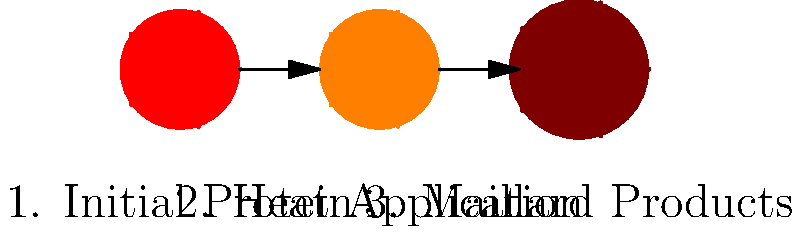As a BBQ Pit Master, you know the Maillard reaction is crucial for developing flavor and color in meats. Based on the protein molecule diagrams above, which stage represents the formation of complex flavor compounds and browning? The Maillard reaction is a complex series of chemical reactions between amino acids and reducing sugars that occurs when proteins are heated. This reaction is responsible for the characteristic flavors and brown color in many cooked foods, especially in grilled and smoked meats. Let's break down the stages shown in the diagram:

1. Initial Protein: This is represented by the red molecule. At this stage, the protein is in its raw, uncooked state.

2. Heat Application: The orange molecule shows the protein as heat is applied. This is when the Maillard reaction begins. The heat causes the protein structure to start changing.

3. Maillard Products: The brown molecule represents the final stage of the Maillard reaction. This is where complex flavor compounds are formed, and browning occurs.

The Maillard reaction produces hundreds of different flavor compounds and brown-colored polymers, known as melanoidins. These are responsible for the complex flavors and attractive brown color in properly cooked meats.

As a BBQ Pit Master, understanding this process allows you to control the development of flavors and achieve the perfect crust on your meats. The third stage (brown molecule) is where you want to get your proteins to develop that rich, complex flavor profile that BBQ enthusiasts crave.
Answer: Stage 3 (brown molecule) 